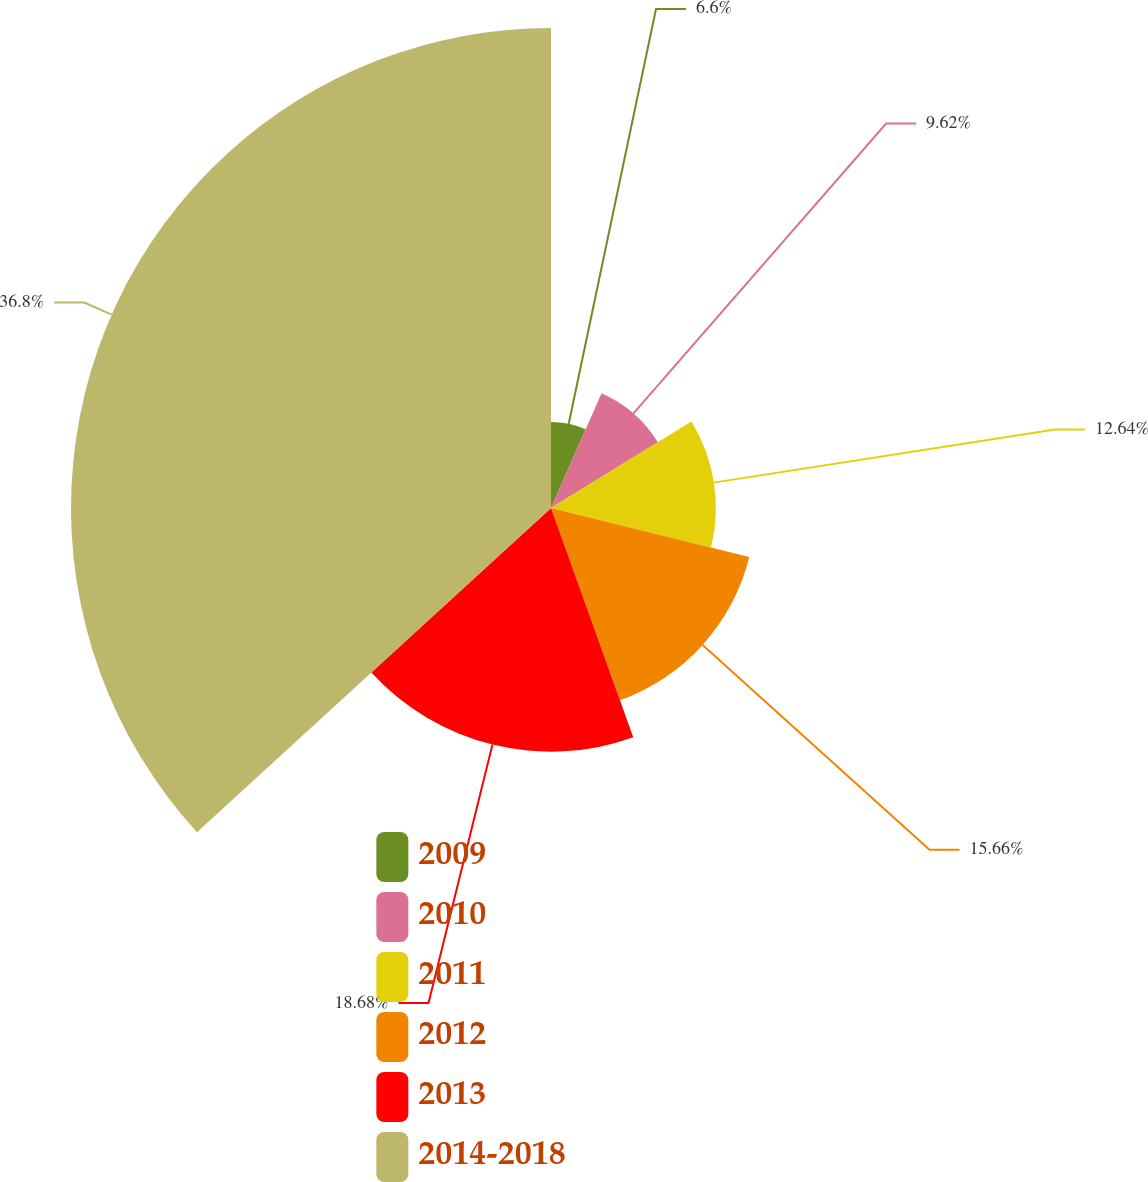Convert chart to OTSL. <chart><loc_0><loc_0><loc_500><loc_500><pie_chart><fcel>2009<fcel>2010<fcel>2011<fcel>2012<fcel>2013<fcel>2014-2018<nl><fcel>6.6%<fcel>9.62%<fcel>12.64%<fcel>15.66%<fcel>18.68%<fcel>36.8%<nl></chart> 